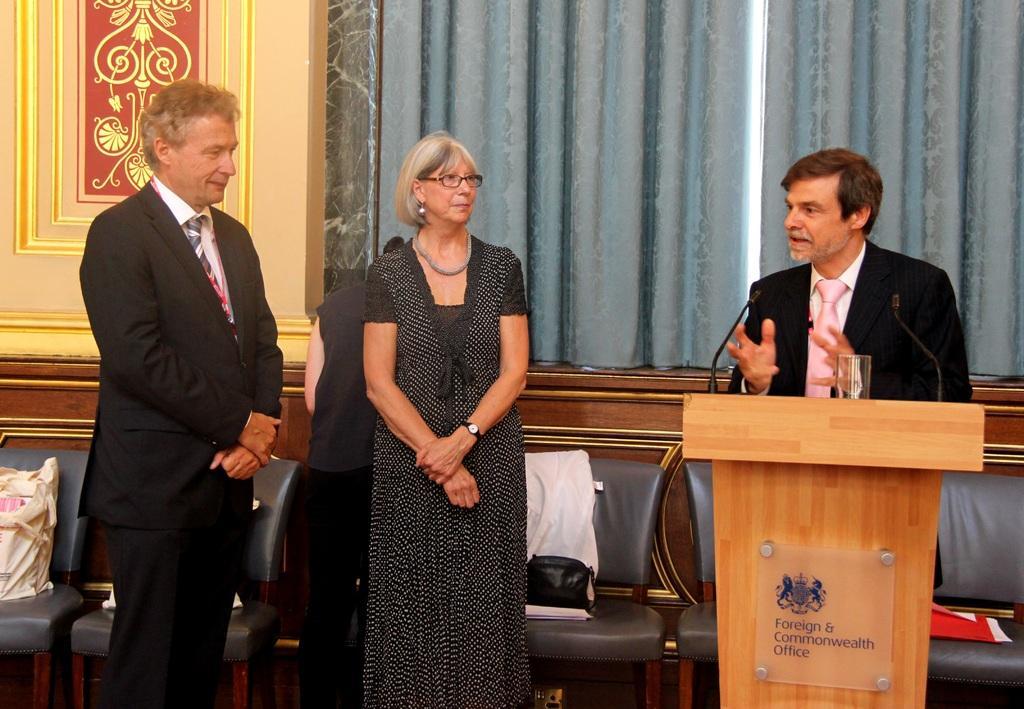Describe this image in one or two sentences. In this image, there are a few people. We can see some chairs with objects. We can also see the podium and some microphones. We can also see a glass and the wall. We can see some curtains. 